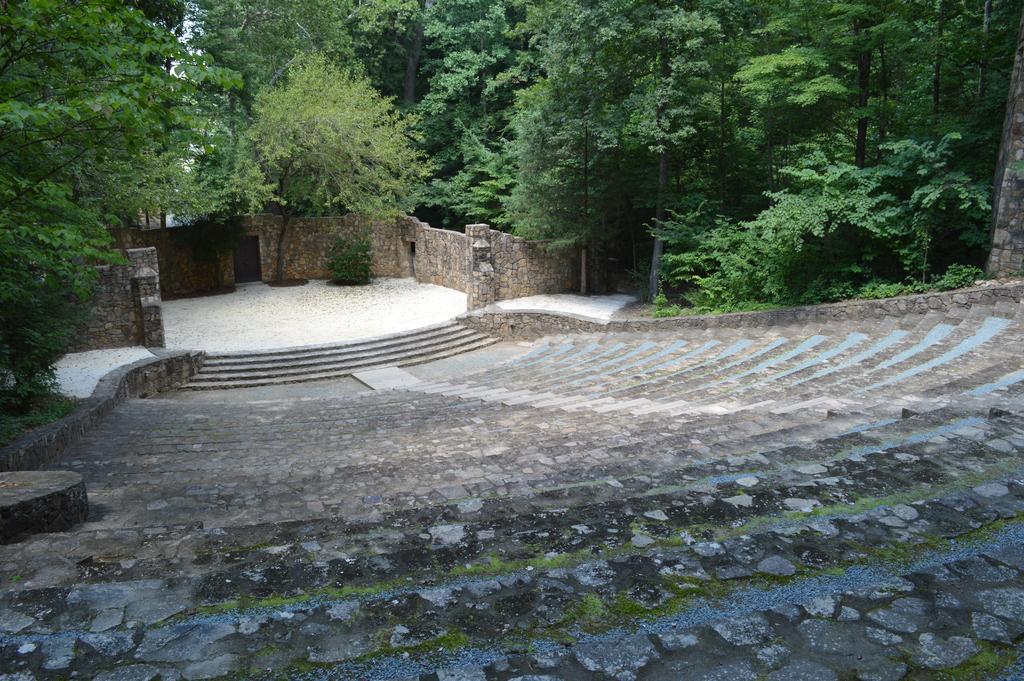Could you give a brief overview of what you see in this image? In this picture I can see trees and I can see stairs. 